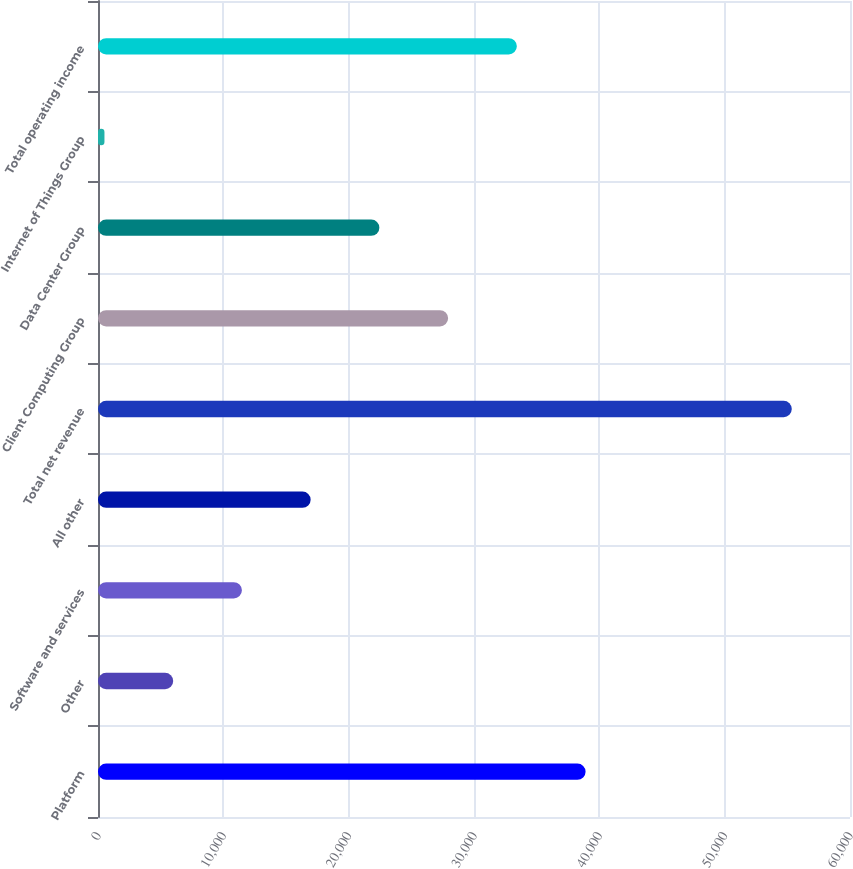Convert chart to OTSL. <chart><loc_0><loc_0><loc_500><loc_500><bar_chart><fcel>Platform<fcel>Other<fcel>Software and services<fcel>All other<fcel>Total net revenue<fcel>Client Computing Group<fcel>Data Center Group<fcel>Internet of Things Group<fcel>Total operating income<nl><fcel>38903<fcel>5999<fcel>11483<fcel>16967<fcel>55355<fcel>27935<fcel>22451<fcel>515<fcel>33419<nl></chart> 